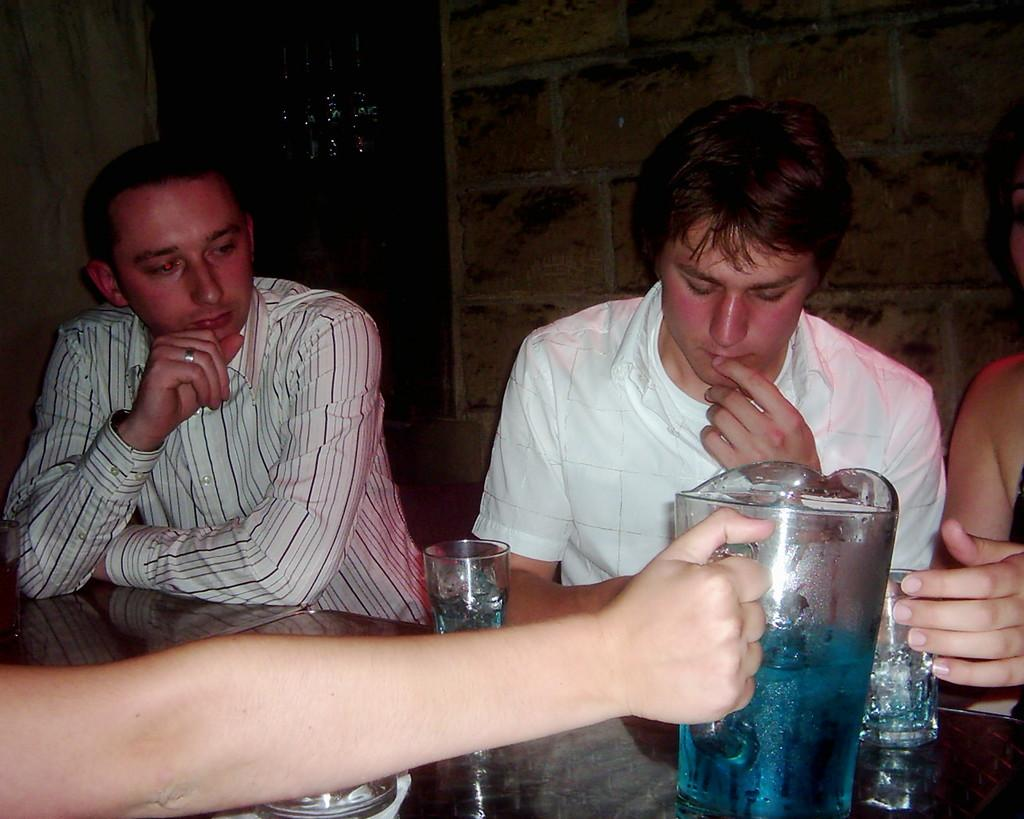What are the people in the image doing? The persons sitting in chairs in the image are likely resting or engaged in conversation. What is on the table in the image? There are glasses and a mug on the table in the image. What can be seen in the background of the image? There is a wall and a door in the background of the image. What type of hose is being used to water the cabbage in the image? There is no hose or cabbage present in the image. Can you see the moon in the image? The image does not show the moon; it only shows a room with people sitting in chairs, a table, and a background with a wall and a door. 